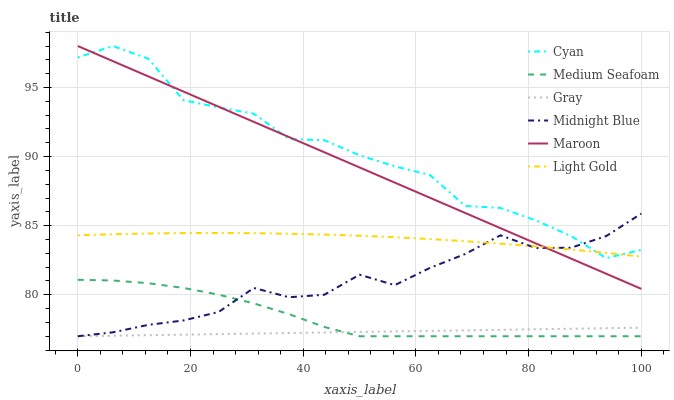Does Gray have the minimum area under the curve?
Answer yes or no. Yes. Does Cyan have the maximum area under the curve?
Answer yes or no. Yes. Does Midnight Blue have the minimum area under the curve?
Answer yes or no. No. Does Midnight Blue have the maximum area under the curve?
Answer yes or no. No. Is Gray the smoothest?
Answer yes or no. Yes. Is Cyan the roughest?
Answer yes or no. Yes. Is Midnight Blue the smoothest?
Answer yes or no. No. Is Midnight Blue the roughest?
Answer yes or no. No. Does Gray have the lowest value?
Answer yes or no. Yes. Does Maroon have the lowest value?
Answer yes or no. No. Does Cyan have the highest value?
Answer yes or no. Yes. Does Midnight Blue have the highest value?
Answer yes or no. No. Is Gray less than Cyan?
Answer yes or no. Yes. Is Light Gold greater than Medium Seafoam?
Answer yes or no. Yes. Does Light Gold intersect Maroon?
Answer yes or no. Yes. Is Light Gold less than Maroon?
Answer yes or no. No. Is Light Gold greater than Maroon?
Answer yes or no. No. Does Gray intersect Cyan?
Answer yes or no. No. 